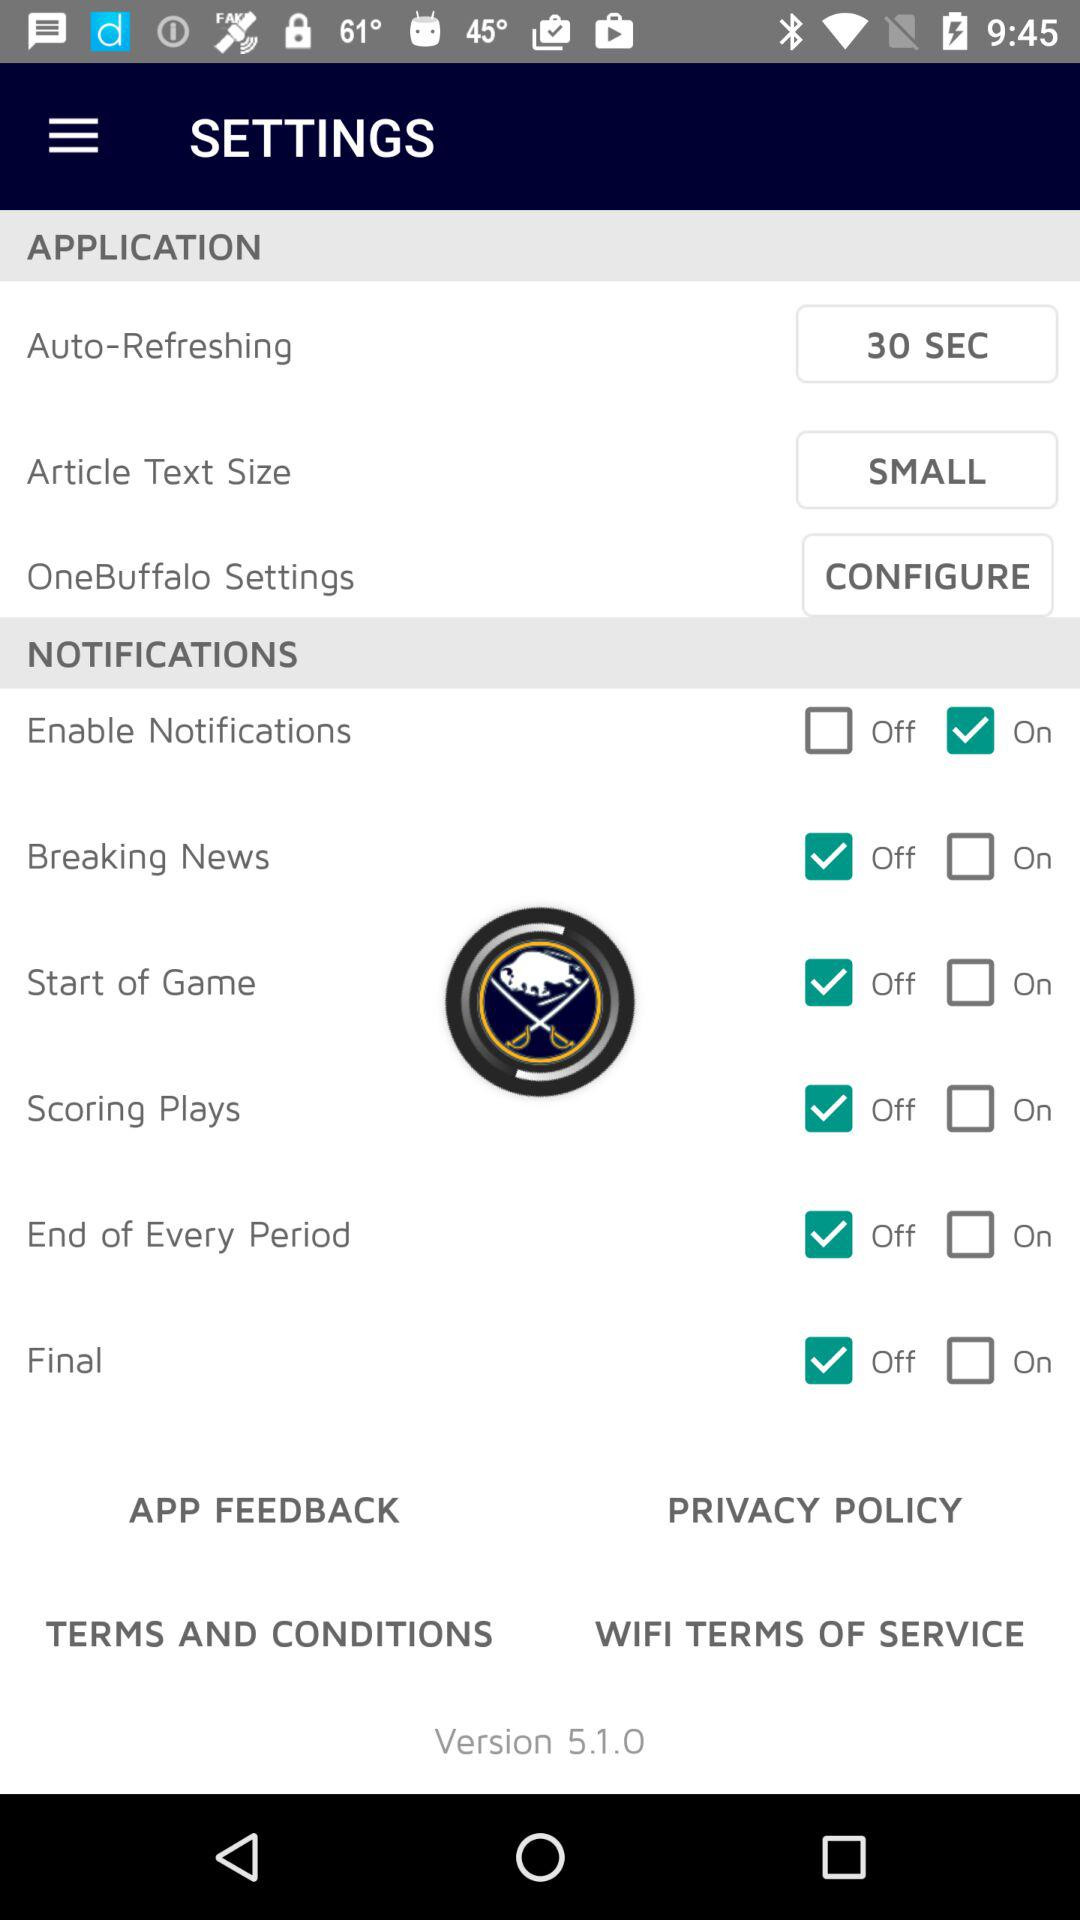What is the article text size? The article text size is "SMALL". 